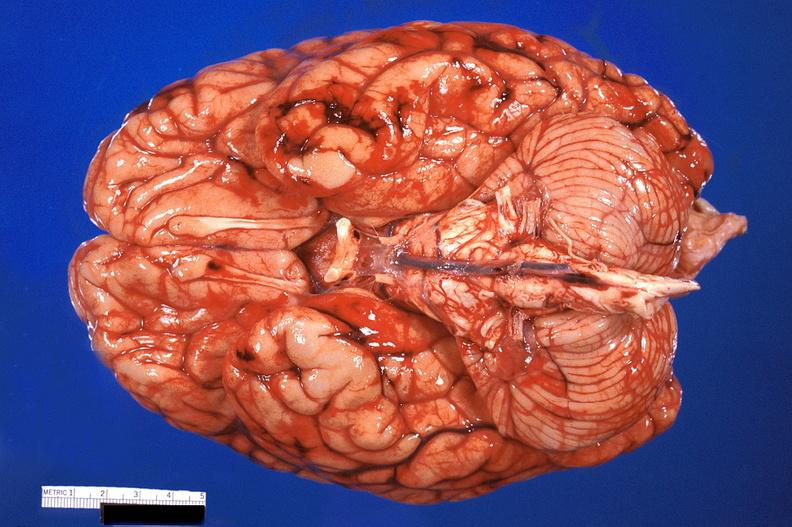what is present?
Answer the question using a single word or phrase. Nervous 